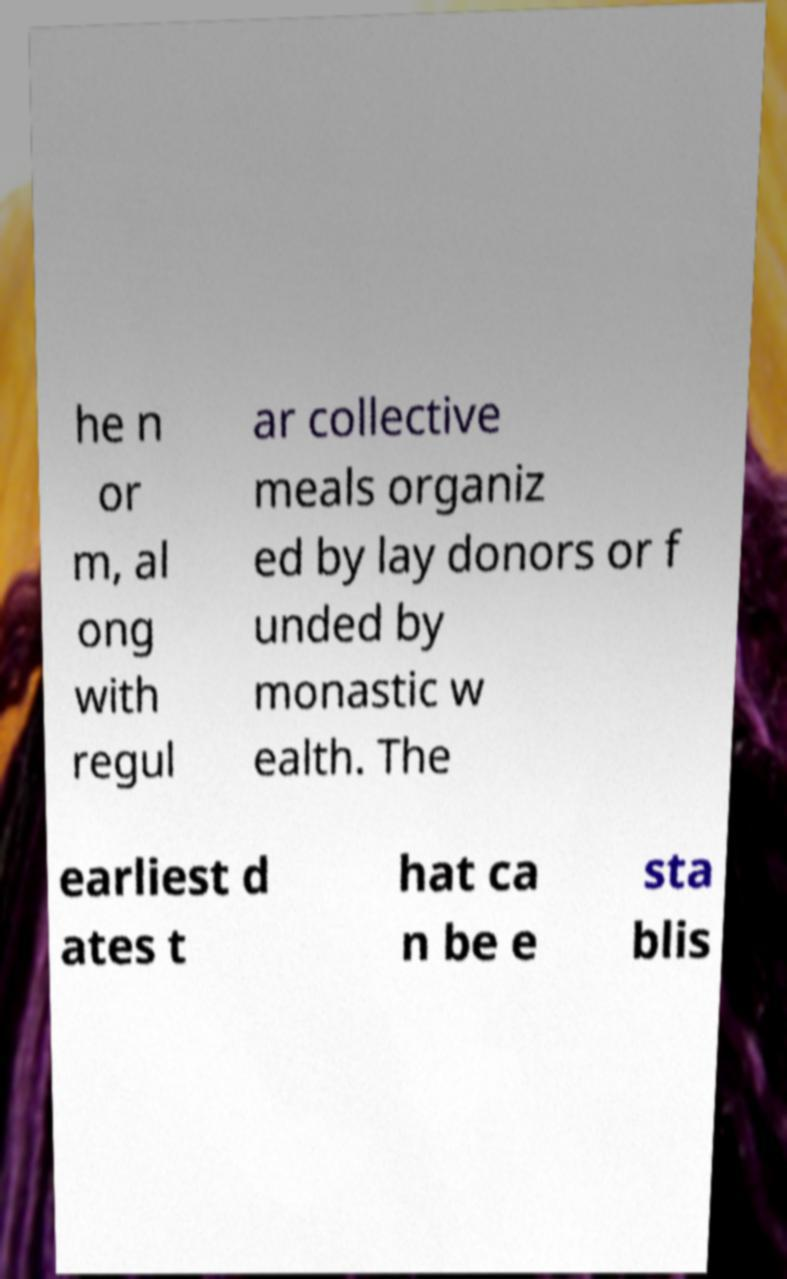Please read and relay the text visible in this image. What does it say? he n or m, al ong with regul ar collective meals organiz ed by lay donors or f unded by monastic w ealth. The earliest d ates t hat ca n be e sta blis 